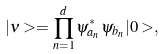<formula> <loc_0><loc_0><loc_500><loc_500>| \nu > = \prod _ { n = 1 } ^ { d } \psi ^ { * } _ { a _ { n } } \psi _ { b _ { n } } | 0 > ,</formula> 